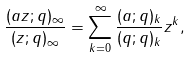Convert formula to latex. <formula><loc_0><loc_0><loc_500><loc_500>\frac { ( a z ; q ) _ { \infty } } { ( z ; q ) _ { \infty } } = \sum _ { k = 0 } ^ { \infty } \frac { ( a ; q ) _ { k } } { ( q ; q ) _ { k } } z ^ { k } ,</formula> 